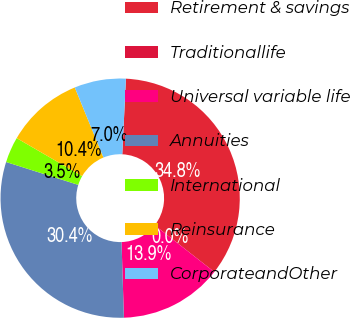Convert chart to OTSL. <chart><loc_0><loc_0><loc_500><loc_500><pie_chart><fcel>Retirement & savings<fcel>Traditionallife<fcel>Universal variable life<fcel>Annuities<fcel>International<fcel>Reinsurance<fcel>CorporateandOther<nl><fcel>34.81%<fcel>0.0%<fcel>13.92%<fcel>30.38%<fcel>3.48%<fcel>10.44%<fcel>6.96%<nl></chart> 